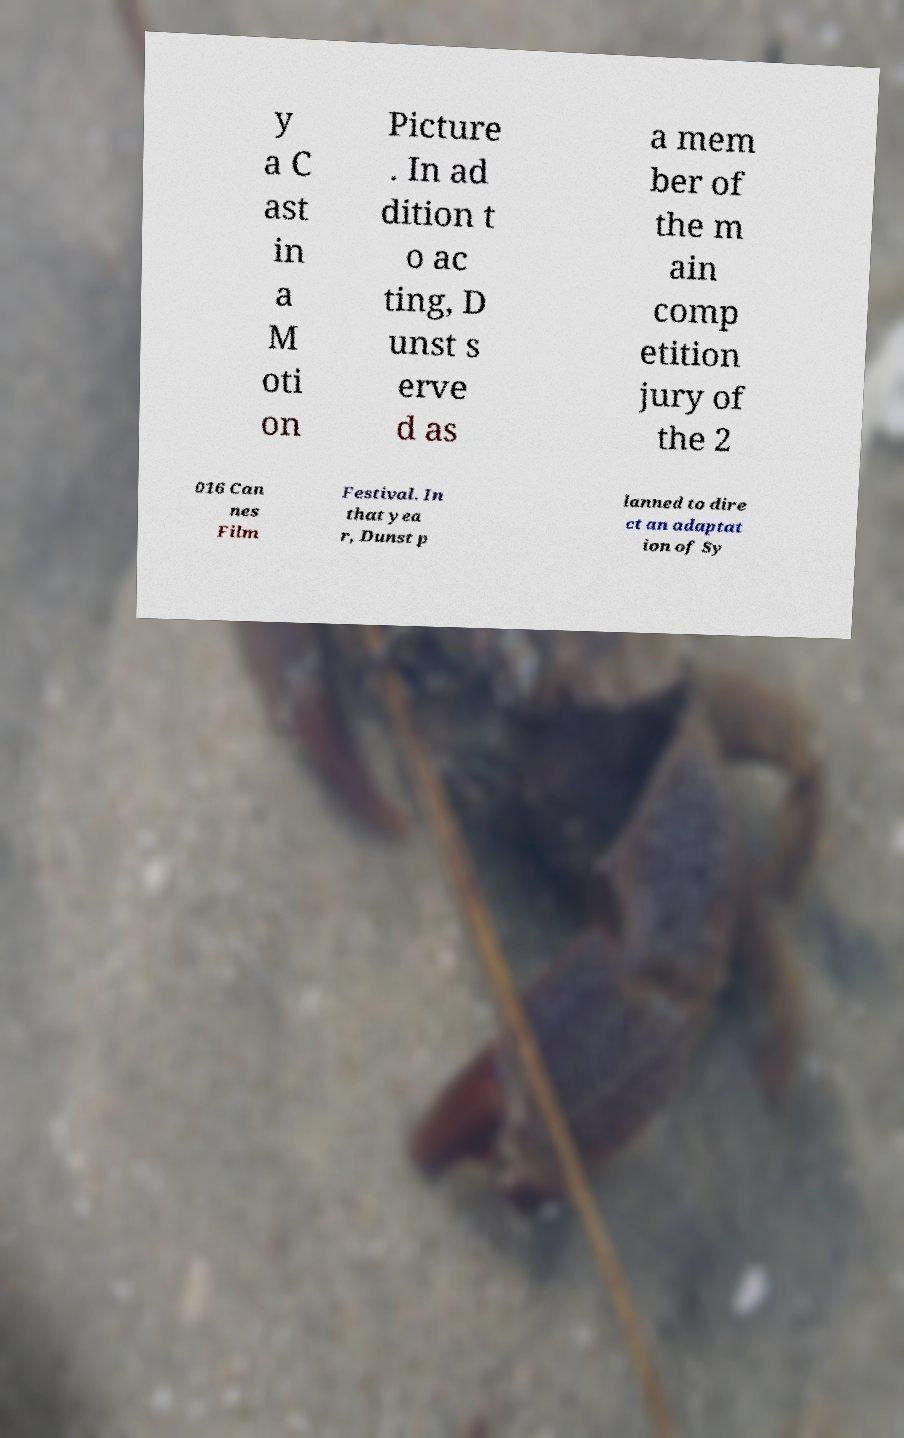Can you read and provide the text displayed in the image?This photo seems to have some interesting text. Can you extract and type it out for me? y a C ast in a M oti on Picture . In ad dition t o ac ting, D unst s erve d as a mem ber of the m ain comp etition jury of the 2 016 Can nes Film Festival. In that yea r, Dunst p lanned to dire ct an adaptat ion of Sy 